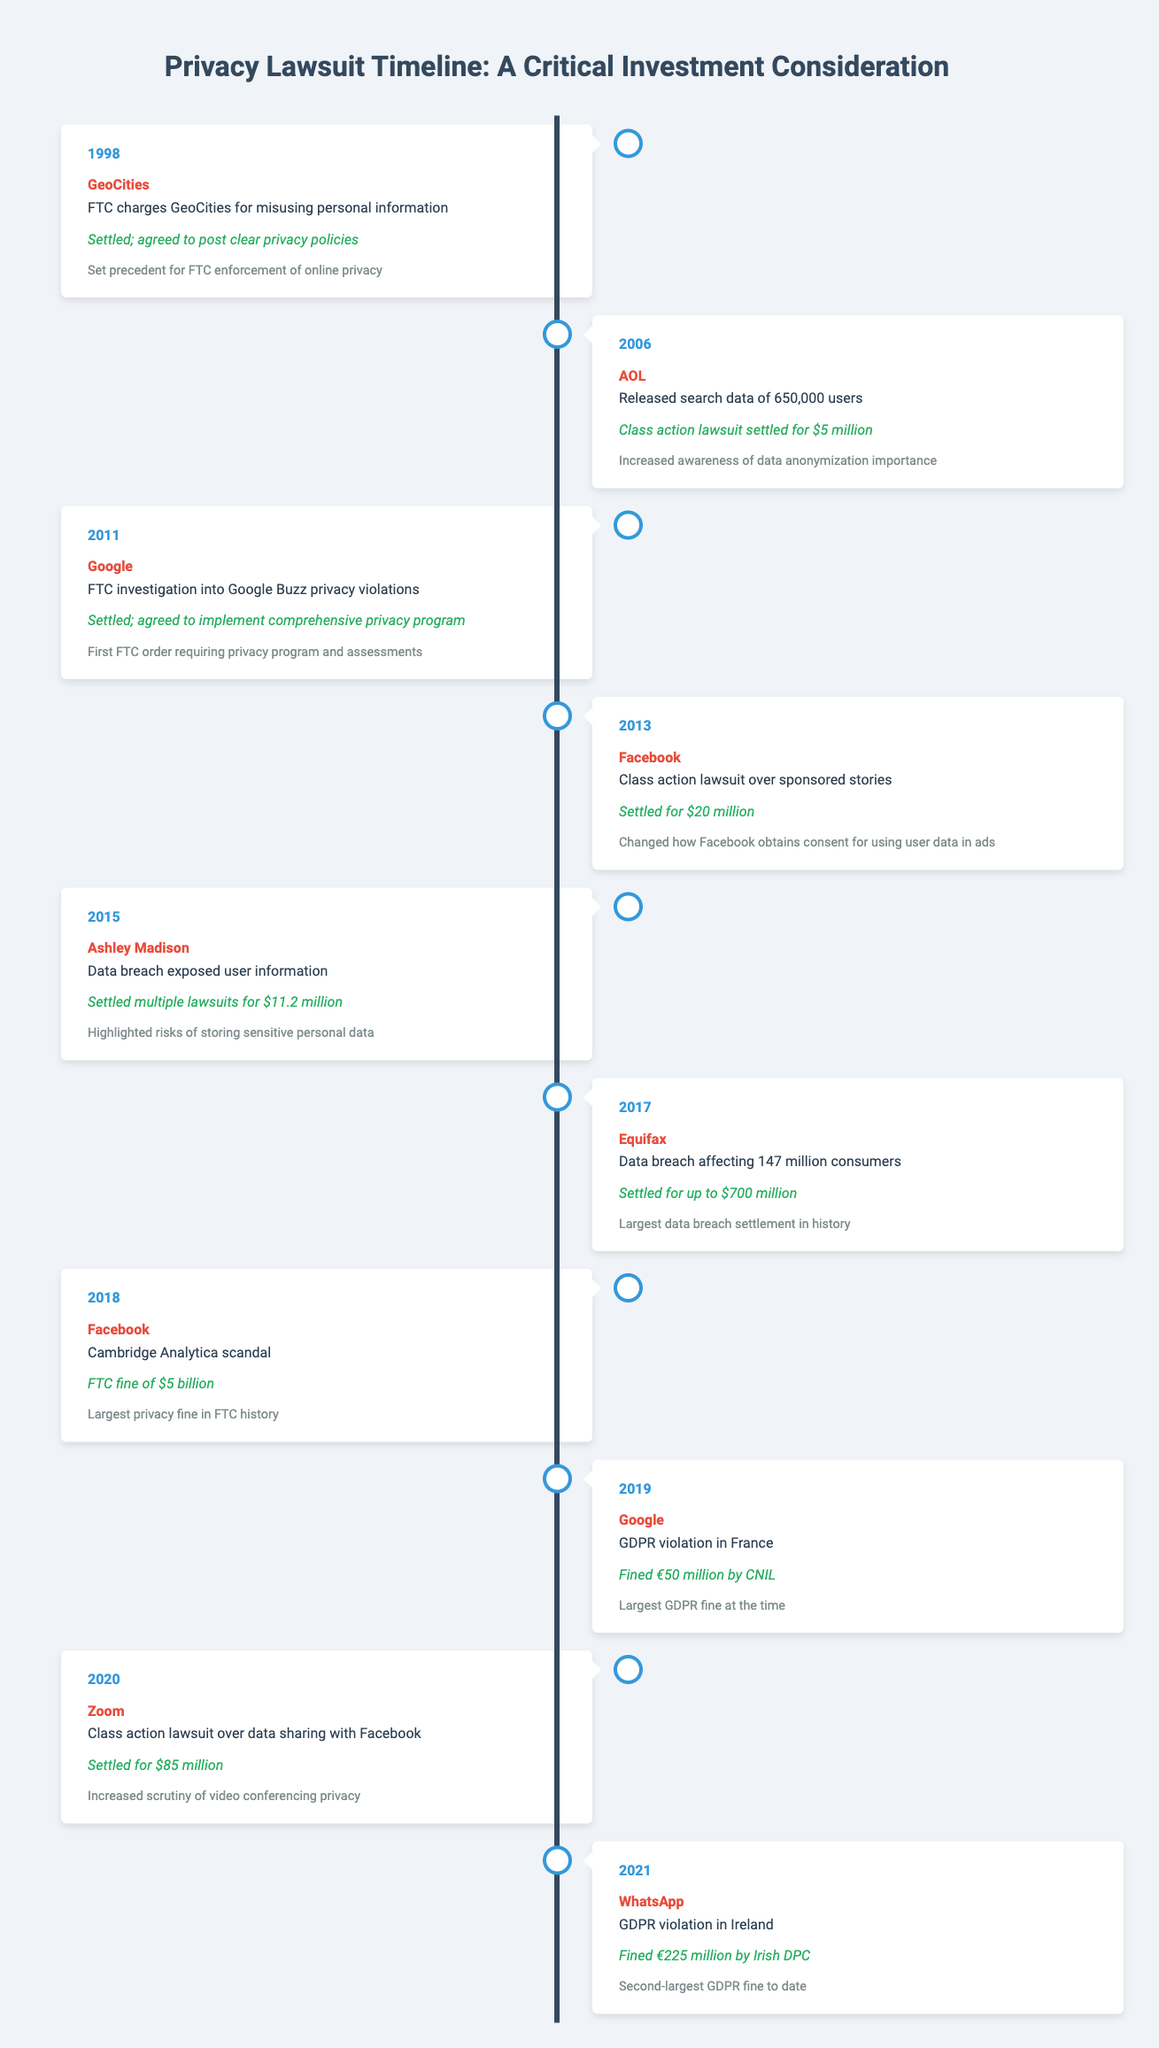What year was the FTC charge against GeoCities? The table indicates that the FTC charged GeoCities in the year 1998.
Answer: 1998 What was the outcome of the class action lawsuit against AOL in 2006? According to the table, the class action lawsuit against AOL settled for $5 million.
Answer: Settled for $5 million Which company had the largest settlement in the timeline? The table states that Equifax had the largest settlement, settling for up to $700 million in 2017.
Answer: Equifax How many total fines were incurred by Google from events listed in the timeline? Google was fined €50 million in 2019 for a GDPR violation and had an FTC investigation in 2011 that resulted in a comprehensive privacy program but no direct fine listed. Thus, the total fines incurred by Google from the table is €50 million.
Answer: €50 million Was there a lawsuit involving Facebook that resulted in a settlement of more than $20 million? Yes, the table shows that in the 2018 Cambridge Analytica scandal, Facebook was fined $5 billion, which is more than $20 million.
Answer: Yes What was the total amount settled for the data breach lawsuits by Ashley Madison and Equifax? The table lists Ashley Madison settling multiple lawsuits for $11.2 million and Equifax for up to $700 million. To find the total, add these amounts: 11.2 million + 700 million = 711.2 million.
Answer: 711.2 million What impact did the 2011 Google investigation have regarding privacy programs? The impact listed for the 2011 Google investigation states that it was the first FTC order requiring a comprehensive privacy program and assessments.
Answer: First FTC order requiring privacy program How does the privacy fine against Facebook in 2018 compare to the 2019 fine against Google? The table shows Facebook's fine in 2018 was $5 billion, while Google's fine in 2019 was €50 million, which is approximately $57 million. Therefore, Facebook's fine was significantly larger than Google's by comparing the two amounts.
Answer: Facebook's fine was larger Which two companies were involved in data breaches that led to settlements exceeding $10 million? The table indicates that Ashley Madison and Equifax both settled lawsuits stemming from data breaches, with Ashley Madison settling for $11.2 million and Equifax for up to $700 million, both exceeding $10 million.
Answer: Ashley Madison and Equifax 